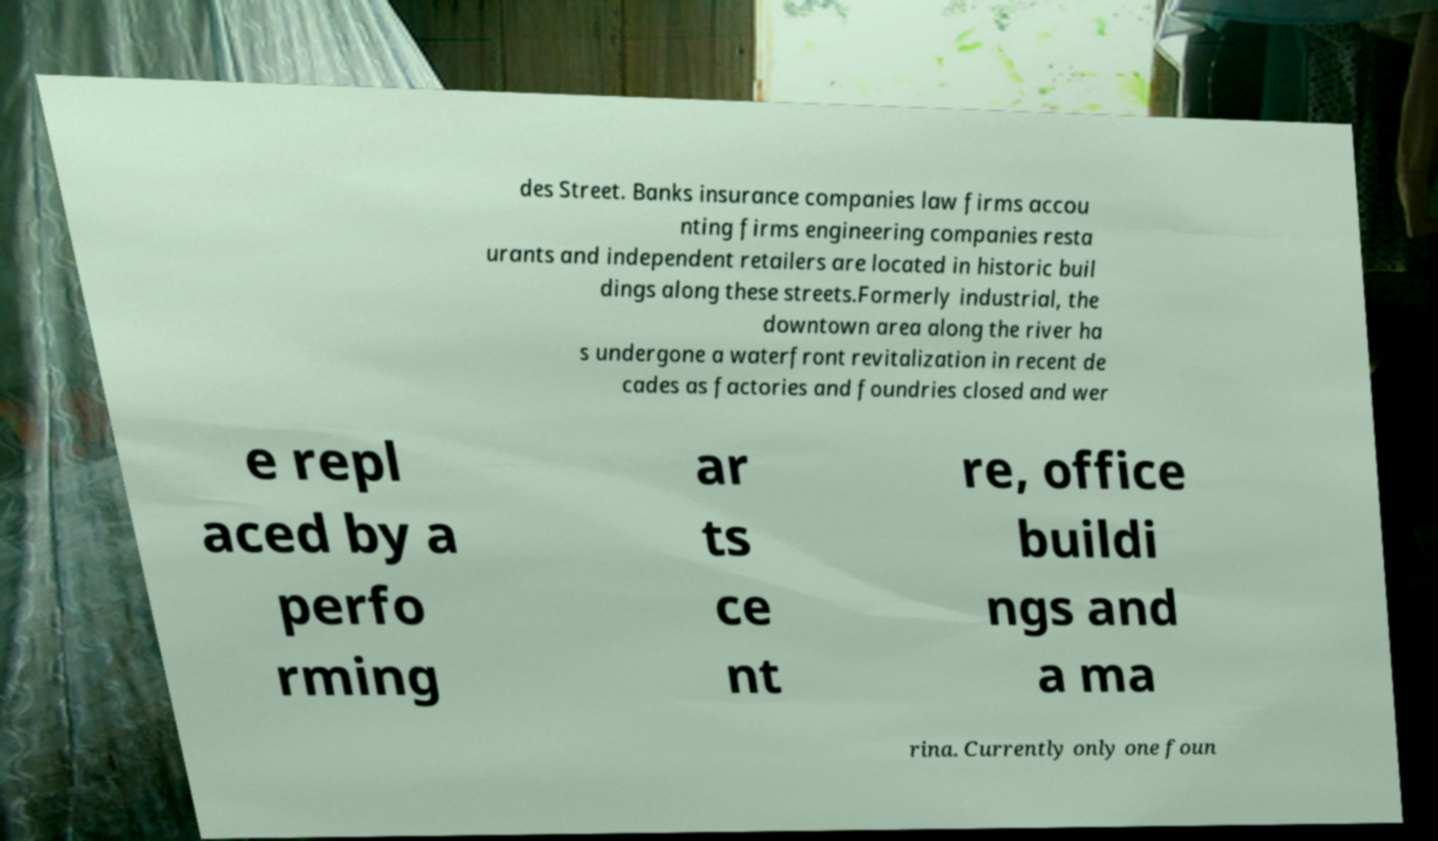Please identify and transcribe the text found in this image. des Street. Banks insurance companies law firms accou nting firms engineering companies resta urants and independent retailers are located in historic buil dings along these streets.Formerly industrial, the downtown area along the river ha s undergone a waterfront revitalization in recent de cades as factories and foundries closed and wer e repl aced by a perfo rming ar ts ce nt re, office buildi ngs and a ma rina. Currently only one foun 